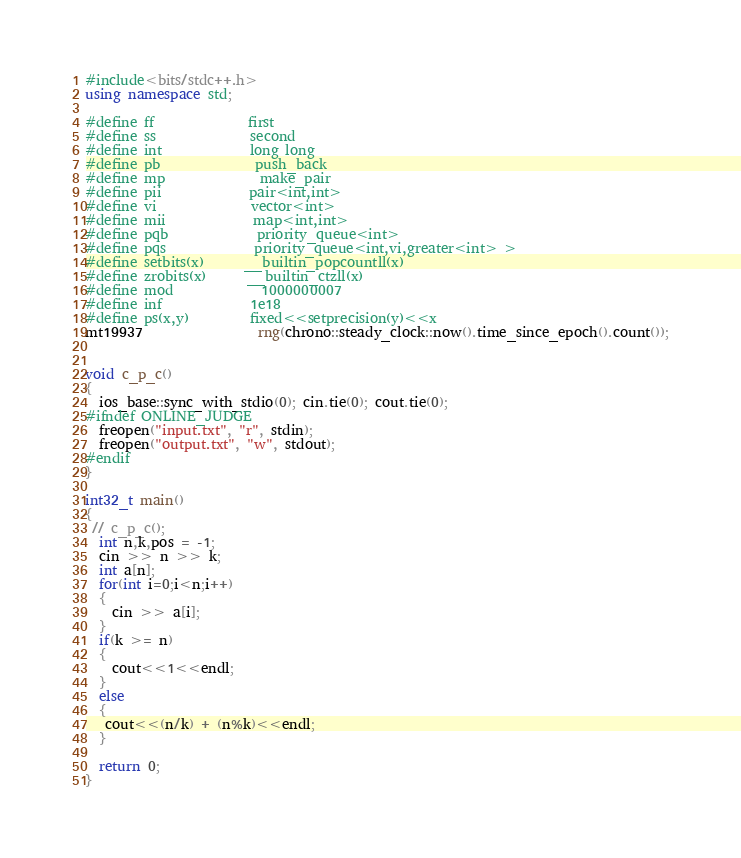Convert code to text. <code><loc_0><loc_0><loc_500><loc_500><_C++_>
#include<bits/stdc++.h>
using namespace std;

#define ff              first
#define ss              second
#define int             long long
#define pb              push_back
#define mp              make_pair
#define pii             pair<int,int>
#define vi              vector<int>
#define mii             map<int,int>
#define pqb             priority_queue<int>
#define pqs             priority_queue<int,vi,greater<int> >
#define setbits(x)      __builtin_popcountll(x)
#define zrobits(x)      __builtin_ctzll(x)
#define mod             1000000007
#define inf             1e18
#define ps(x,y)         fixed<<setprecision(y)<<x
mt19937                 rng(chrono::steady_clock::now().time_since_epoch().count());


void c_p_c()
{
  ios_base::sync_with_stdio(0); cin.tie(0); cout.tie(0);
#ifndef ONLINE_JUDGE
  freopen("input.txt", "r", stdin);
  freopen("output.txt", "w", stdout);
#endif
}

int32_t main()
{
 // c_p_c();
  int n,k,pos = -1;
  cin >> n >> k;
  int a[n];
  for(int i=0;i<n;i++)
  {
    cin >> a[i];
  }
  if(k >= n)
  {
    cout<<1<<endl;
  }
  else
  {
   cout<<(n/k) + (n%k)<<endl;  
  }
  
  return 0;
}

</code> 